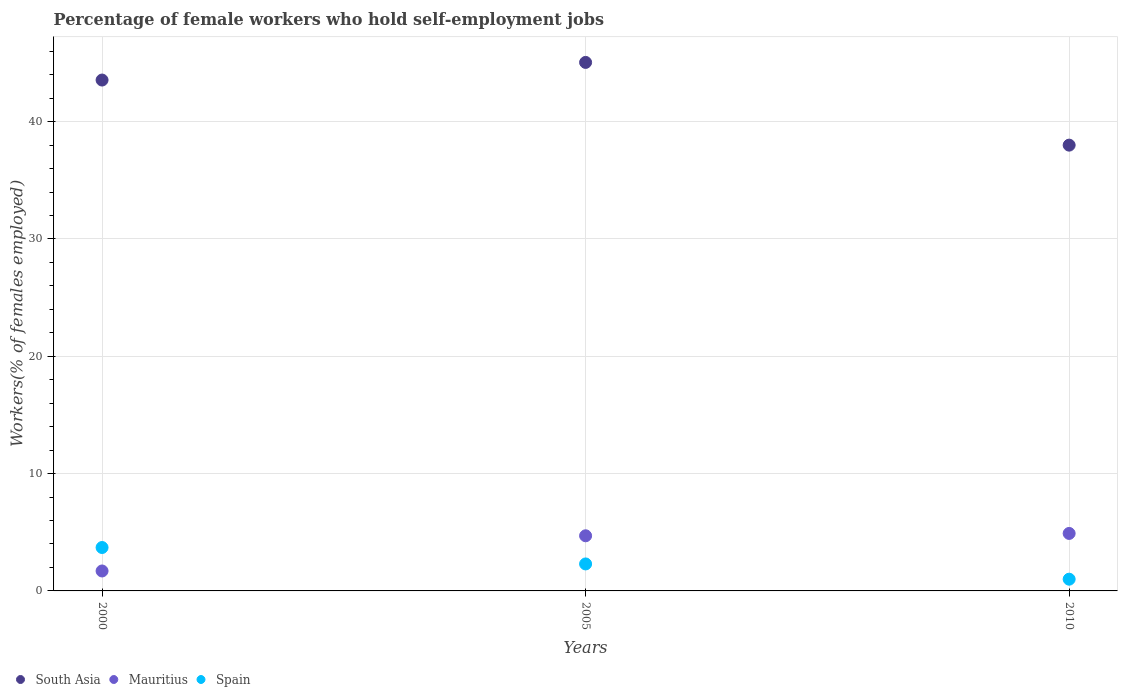Is the number of dotlines equal to the number of legend labels?
Keep it short and to the point. Yes. Across all years, what is the maximum percentage of self-employed female workers in Mauritius?
Your response must be concise. 4.9. Across all years, what is the minimum percentage of self-employed female workers in Mauritius?
Give a very brief answer. 1.7. In which year was the percentage of self-employed female workers in South Asia maximum?
Offer a terse response. 2005. In which year was the percentage of self-employed female workers in South Asia minimum?
Make the answer very short. 2010. What is the total percentage of self-employed female workers in South Asia in the graph?
Your answer should be compact. 126.59. What is the difference between the percentage of self-employed female workers in Mauritius in 2005 and that in 2010?
Your answer should be very brief. -0.2. What is the difference between the percentage of self-employed female workers in South Asia in 2005 and the percentage of self-employed female workers in Mauritius in 2000?
Give a very brief answer. 43.35. What is the average percentage of self-employed female workers in Spain per year?
Your response must be concise. 2.33. In the year 2005, what is the difference between the percentage of self-employed female workers in Spain and percentage of self-employed female workers in Mauritius?
Ensure brevity in your answer.  -2.4. What is the ratio of the percentage of self-employed female workers in South Asia in 2005 to that in 2010?
Your answer should be compact. 1.19. Is the percentage of self-employed female workers in Mauritius in 2005 less than that in 2010?
Your response must be concise. Yes. Is the difference between the percentage of self-employed female workers in Spain in 2000 and 2005 greater than the difference between the percentage of self-employed female workers in Mauritius in 2000 and 2005?
Ensure brevity in your answer.  Yes. What is the difference between the highest and the second highest percentage of self-employed female workers in South Asia?
Provide a succinct answer. 1.5. What is the difference between the highest and the lowest percentage of self-employed female workers in Mauritius?
Make the answer very short. 3.2. In how many years, is the percentage of self-employed female workers in Spain greater than the average percentage of self-employed female workers in Spain taken over all years?
Your response must be concise. 1. Is it the case that in every year, the sum of the percentage of self-employed female workers in Mauritius and percentage of self-employed female workers in Spain  is greater than the percentage of self-employed female workers in South Asia?
Your response must be concise. No. Does the percentage of self-employed female workers in Mauritius monotonically increase over the years?
Your response must be concise. Yes. How many years are there in the graph?
Your answer should be compact. 3. Does the graph contain any zero values?
Offer a very short reply. No. Does the graph contain grids?
Your answer should be very brief. Yes. How many legend labels are there?
Ensure brevity in your answer.  3. How are the legend labels stacked?
Your answer should be compact. Horizontal. What is the title of the graph?
Provide a short and direct response. Percentage of female workers who hold self-employment jobs. What is the label or title of the Y-axis?
Ensure brevity in your answer.  Workers(% of females employed). What is the Workers(% of females employed) in South Asia in 2000?
Offer a very short reply. 43.55. What is the Workers(% of females employed) in Mauritius in 2000?
Provide a short and direct response. 1.7. What is the Workers(% of females employed) in Spain in 2000?
Offer a terse response. 3.7. What is the Workers(% of females employed) of South Asia in 2005?
Keep it short and to the point. 45.05. What is the Workers(% of females employed) of Mauritius in 2005?
Your response must be concise. 4.7. What is the Workers(% of females employed) in Spain in 2005?
Give a very brief answer. 2.3. What is the Workers(% of females employed) of South Asia in 2010?
Keep it short and to the point. 38. What is the Workers(% of females employed) of Mauritius in 2010?
Offer a very short reply. 4.9. Across all years, what is the maximum Workers(% of females employed) in South Asia?
Ensure brevity in your answer.  45.05. Across all years, what is the maximum Workers(% of females employed) in Mauritius?
Provide a short and direct response. 4.9. Across all years, what is the maximum Workers(% of females employed) in Spain?
Provide a succinct answer. 3.7. Across all years, what is the minimum Workers(% of females employed) in South Asia?
Your response must be concise. 38. Across all years, what is the minimum Workers(% of females employed) in Mauritius?
Offer a terse response. 1.7. Across all years, what is the minimum Workers(% of females employed) in Spain?
Offer a very short reply. 1. What is the total Workers(% of females employed) of South Asia in the graph?
Offer a terse response. 126.59. What is the total Workers(% of females employed) of Mauritius in the graph?
Provide a succinct answer. 11.3. What is the difference between the Workers(% of females employed) in South Asia in 2000 and that in 2005?
Make the answer very short. -1.5. What is the difference between the Workers(% of females employed) of Spain in 2000 and that in 2005?
Offer a very short reply. 1.4. What is the difference between the Workers(% of females employed) of South Asia in 2000 and that in 2010?
Make the answer very short. 5.55. What is the difference between the Workers(% of females employed) in Spain in 2000 and that in 2010?
Your response must be concise. 2.7. What is the difference between the Workers(% of females employed) in South Asia in 2005 and that in 2010?
Your answer should be very brief. 7.05. What is the difference between the Workers(% of females employed) of Mauritius in 2005 and that in 2010?
Make the answer very short. -0.2. What is the difference between the Workers(% of females employed) in South Asia in 2000 and the Workers(% of females employed) in Mauritius in 2005?
Your answer should be very brief. 38.85. What is the difference between the Workers(% of females employed) of South Asia in 2000 and the Workers(% of females employed) of Spain in 2005?
Give a very brief answer. 41.25. What is the difference between the Workers(% of females employed) of South Asia in 2000 and the Workers(% of females employed) of Mauritius in 2010?
Make the answer very short. 38.65. What is the difference between the Workers(% of females employed) in South Asia in 2000 and the Workers(% of females employed) in Spain in 2010?
Provide a succinct answer. 42.55. What is the difference between the Workers(% of females employed) in Mauritius in 2000 and the Workers(% of females employed) in Spain in 2010?
Keep it short and to the point. 0.7. What is the difference between the Workers(% of females employed) of South Asia in 2005 and the Workers(% of females employed) of Mauritius in 2010?
Offer a very short reply. 40.15. What is the difference between the Workers(% of females employed) of South Asia in 2005 and the Workers(% of females employed) of Spain in 2010?
Your answer should be compact. 44.05. What is the average Workers(% of females employed) of South Asia per year?
Provide a succinct answer. 42.2. What is the average Workers(% of females employed) in Mauritius per year?
Make the answer very short. 3.77. What is the average Workers(% of females employed) of Spain per year?
Your answer should be very brief. 2.33. In the year 2000, what is the difference between the Workers(% of females employed) in South Asia and Workers(% of females employed) in Mauritius?
Offer a terse response. 41.85. In the year 2000, what is the difference between the Workers(% of females employed) of South Asia and Workers(% of females employed) of Spain?
Your response must be concise. 39.85. In the year 2005, what is the difference between the Workers(% of females employed) in South Asia and Workers(% of females employed) in Mauritius?
Offer a very short reply. 40.35. In the year 2005, what is the difference between the Workers(% of females employed) in South Asia and Workers(% of females employed) in Spain?
Provide a short and direct response. 42.75. In the year 2010, what is the difference between the Workers(% of females employed) in South Asia and Workers(% of females employed) in Mauritius?
Your response must be concise. 33.1. In the year 2010, what is the difference between the Workers(% of females employed) in South Asia and Workers(% of females employed) in Spain?
Keep it short and to the point. 37. What is the ratio of the Workers(% of females employed) in South Asia in 2000 to that in 2005?
Give a very brief answer. 0.97. What is the ratio of the Workers(% of females employed) in Mauritius in 2000 to that in 2005?
Keep it short and to the point. 0.36. What is the ratio of the Workers(% of females employed) of Spain in 2000 to that in 2005?
Give a very brief answer. 1.61. What is the ratio of the Workers(% of females employed) of South Asia in 2000 to that in 2010?
Keep it short and to the point. 1.15. What is the ratio of the Workers(% of females employed) of Mauritius in 2000 to that in 2010?
Your response must be concise. 0.35. What is the ratio of the Workers(% of females employed) of Spain in 2000 to that in 2010?
Your answer should be compact. 3.7. What is the ratio of the Workers(% of females employed) of South Asia in 2005 to that in 2010?
Provide a short and direct response. 1.19. What is the ratio of the Workers(% of females employed) in Mauritius in 2005 to that in 2010?
Provide a short and direct response. 0.96. What is the difference between the highest and the second highest Workers(% of females employed) of South Asia?
Make the answer very short. 1.5. What is the difference between the highest and the second highest Workers(% of females employed) of Spain?
Provide a short and direct response. 1.4. What is the difference between the highest and the lowest Workers(% of females employed) of South Asia?
Keep it short and to the point. 7.05. What is the difference between the highest and the lowest Workers(% of females employed) of Spain?
Your answer should be very brief. 2.7. 